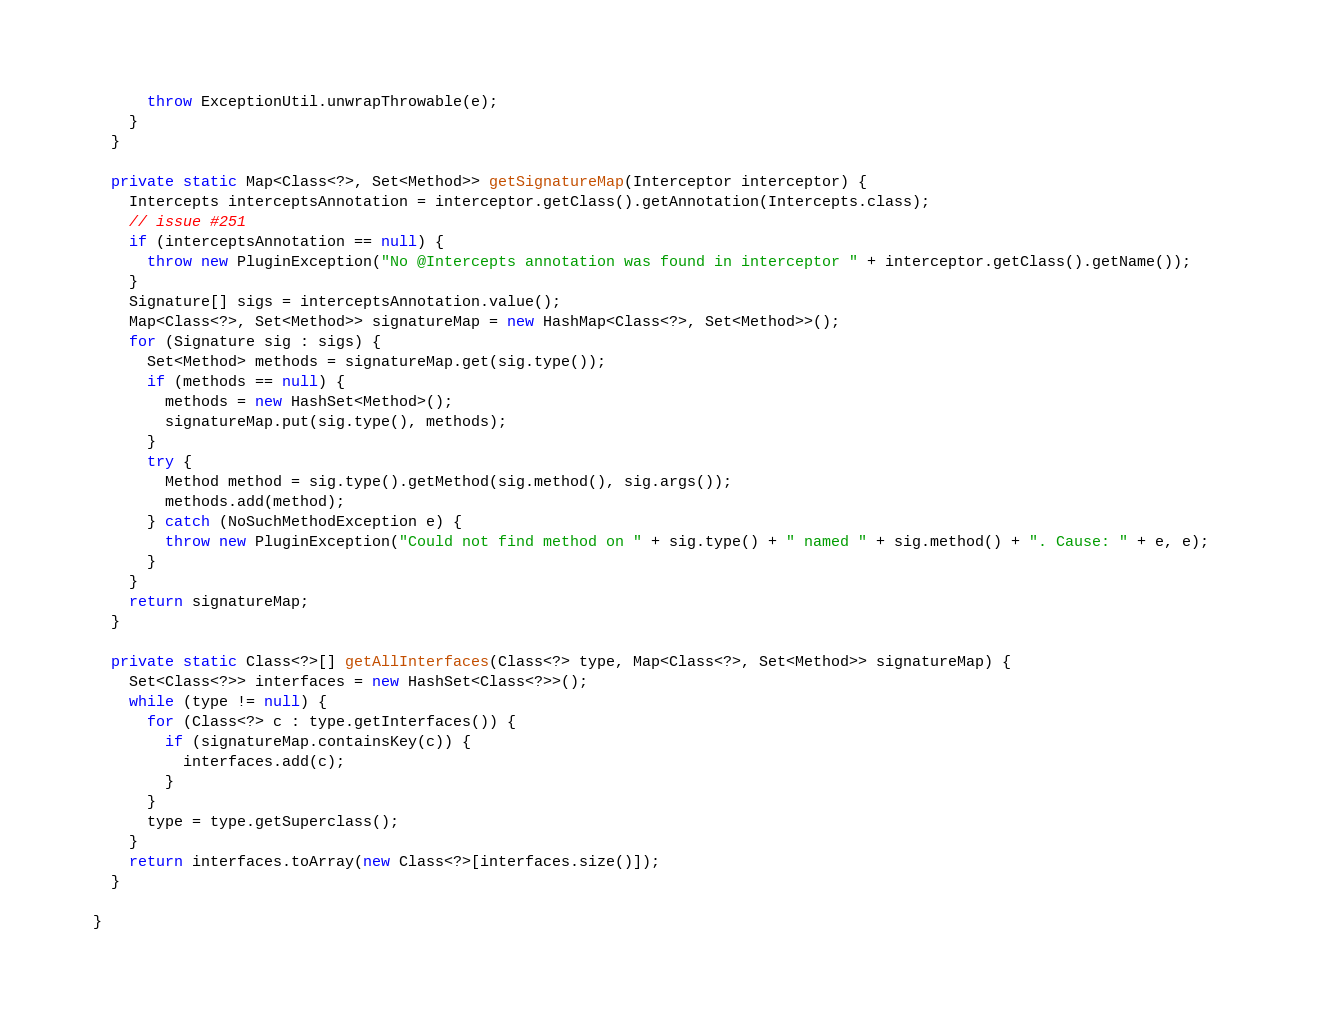<code> <loc_0><loc_0><loc_500><loc_500><_Java_>      throw ExceptionUtil.unwrapThrowable(e);
    }
  }

  private static Map<Class<?>, Set<Method>> getSignatureMap(Interceptor interceptor) {
    Intercepts interceptsAnnotation = interceptor.getClass().getAnnotation(Intercepts.class);
    // issue #251
    if (interceptsAnnotation == null) {
      throw new PluginException("No @Intercepts annotation was found in interceptor " + interceptor.getClass().getName());      
    }
    Signature[] sigs = interceptsAnnotation.value();
    Map<Class<?>, Set<Method>> signatureMap = new HashMap<Class<?>, Set<Method>>();
    for (Signature sig : sigs) {
      Set<Method> methods = signatureMap.get(sig.type());
      if (methods == null) {
        methods = new HashSet<Method>();
        signatureMap.put(sig.type(), methods);
      }
      try {
        Method method = sig.type().getMethod(sig.method(), sig.args());
        methods.add(method);
      } catch (NoSuchMethodException e) {
        throw new PluginException("Could not find method on " + sig.type() + " named " + sig.method() + ". Cause: " + e, e);
      }
    }
    return signatureMap;
  }

  private static Class<?>[] getAllInterfaces(Class<?> type, Map<Class<?>, Set<Method>> signatureMap) {
    Set<Class<?>> interfaces = new HashSet<Class<?>>();
    while (type != null) {
      for (Class<?> c : type.getInterfaces()) {
        if (signatureMap.containsKey(c)) {
          interfaces.add(c);
        }
      }
      type = type.getSuperclass();
    }
    return interfaces.toArray(new Class<?>[interfaces.size()]);
  }

}
</code> 